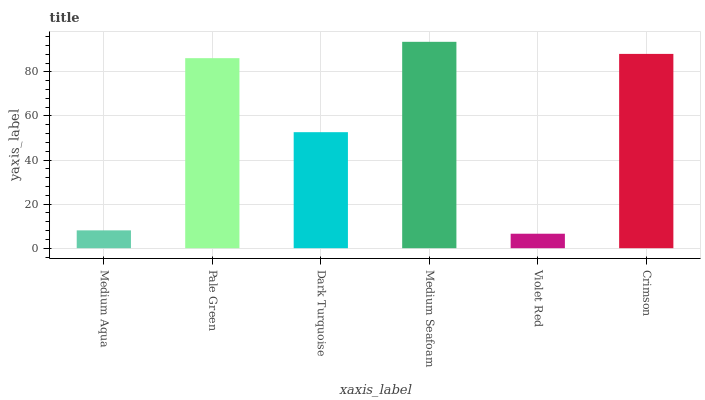Is Violet Red the minimum?
Answer yes or no. Yes. Is Medium Seafoam the maximum?
Answer yes or no. Yes. Is Pale Green the minimum?
Answer yes or no. No. Is Pale Green the maximum?
Answer yes or no. No. Is Pale Green greater than Medium Aqua?
Answer yes or no. Yes. Is Medium Aqua less than Pale Green?
Answer yes or no. Yes. Is Medium Aqua greater than Pale Green?
Answer yes or no. No. Is Pale Green less than Medium Aqua?
Answer yes or no. No. Is Pale Green the high median?
Answer yes or no. Yes. Is Dark Turquoise the low median?
Answer yes or no. Yes. Is Dark Turquoise the high median?
Answer yes or no. No. Is Medium Seafoam the low median?
Answer yes or no. No. 